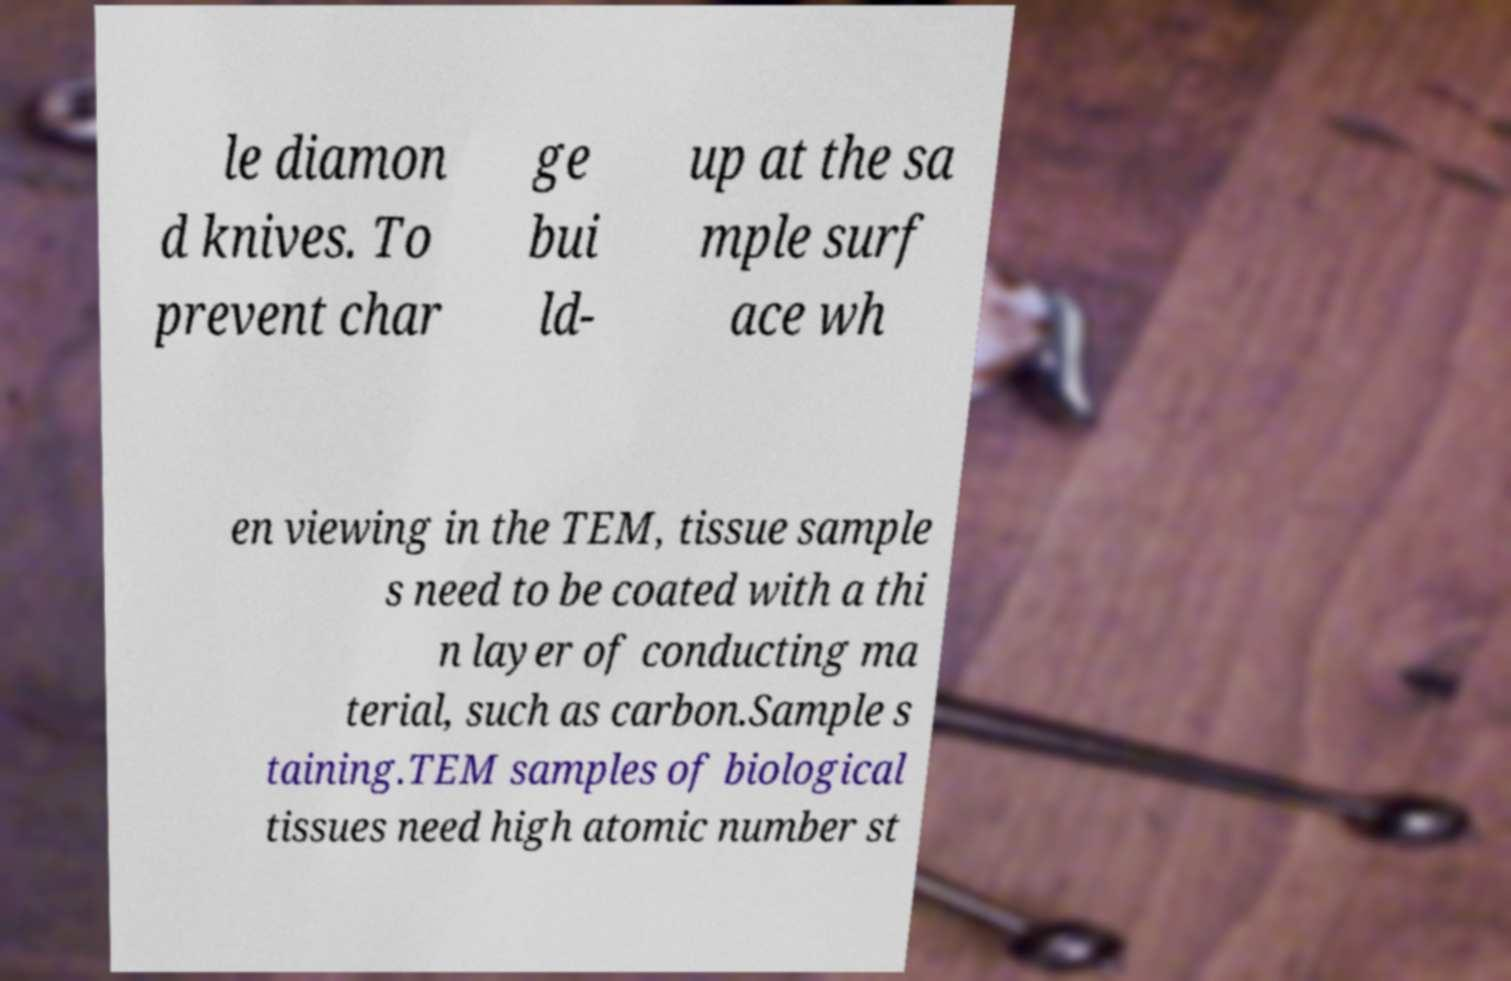Can you read and provide the text displayed in the image?This photo seems to have some interesting text. Can you extract and type it out for me? le diamon d knives. To prevent char ge bui ld- up at the sa mple surf ace wh en viewing in the TEM, tissue sample s need to be coated with a thi n layer of conducting ma terial, such as carbon.Sample s taining.TEM samples of biological tissues need high atomic number st 